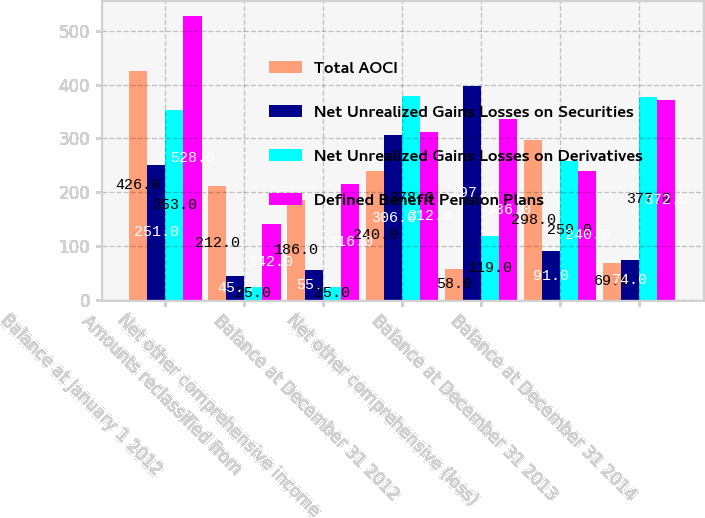Convert chart to OTSL. <chart><loc_0><loc_0><loc_500><loc_500><stacked_bar_chart><ecel><fcel>Balance at January 1 2012<fcel>Amounts reclassified from<fcel>Net other comprehensive income<fcel>Balance at December 31 2012<fcel>Net other comprehensive (loss)<fcel>Balance at December 31 2013<fcel>Balance at December 31 2014<nl><fcel>Total AOCI<fcel>426<fcel>212<fcel>186<fcel>240<fcel>58<fcel>298<fcel>69<nl><fcel>Net Unrealized Gains Losses on Securities<fcel>251<fcel>45<fcel>55<fcel>306<fcel>397<fcel>91<fcel>74<nl><fcel>Net Unrealized Gains Losses on Derivatives<fcel>353<fcel>25<fcel>25<fcel>378<fcel>119<fcel>259<fcel>377<nl><fcel>Defined Benefit Pension Plans<fcel>528<fcel>142<fcel>216<fcel>312<fcel>336<fcel>240<fcel>372<nl></chart> 